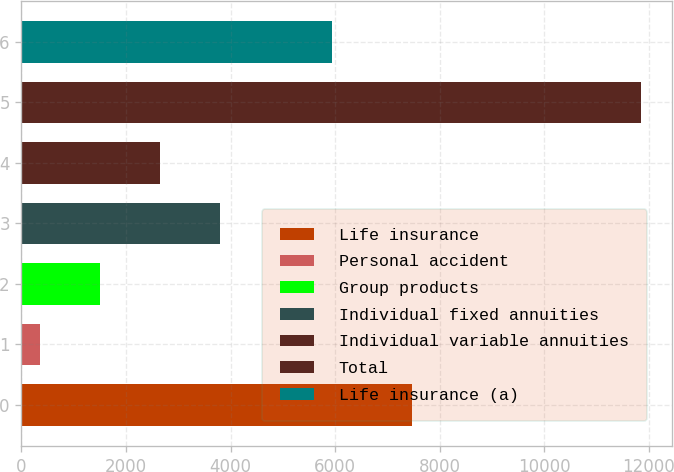Convert chart. <chart><loc_0><loc_0><loc_500><loc_500><bar_chart><fcel>Life insurance<fcel>Personal accident<fcel>Group products<fcel>Individual fixed annuities<fcel>Individual variable annuities<fcel>Total<fcel>Life insurance (a)<nl><fcel>7473<fcel>354<fcel>1503.5<fcel>3802.5<fcel>2653<fcel>11849<fcel>5937<nl></chart> 